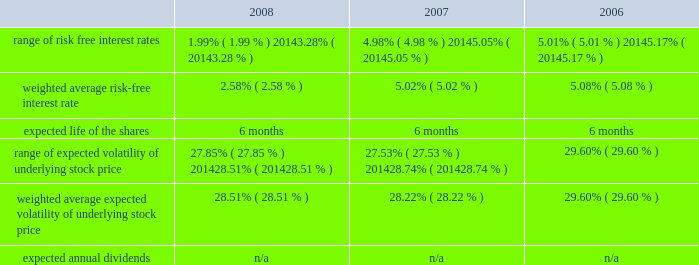American tower corporation and subsidiaries notes to consolidated financial statements 2014 ( continued ) from december 1 through may 31 of each year .
During the 2008 , 2007 and 2006 offering periods employees purchased 55764 , 48886 and 53210 shares , respectively , at weighted average prices per share of $ 30.08 , $ 33.93 and $ 24.98 , respectively .
The fair value of the espp offerings is estimated on the offering period commencement date using a black-scholes pricing model with the expense recognized over the expected life , which is the six month offering period over which employees accumulate payroll deductions to purchase the company 2019s common stock .
The weighted average fair value for the espp shares purchased during 2008 , 2007 and 2006 were $ 7.89 , $ 9.09 and $ 6.79 , respectively .
At december 31 , 2008 , 8.8 million shares remain reserved for future issuance under the plan .
Key assumptions used to apply this pricing model for the years ended december 31 , are as follows: .
13 .
Stockholders 2019 equity warrants 2014in january 2003 , the company issued warrants to purchase approximately 11.4 million shares of its common stock in connection with an offering of 808000 units , each consisting of $ 1000 principal amount at maturity of ati 12.25% ( 12.25 % ) senior subordinated discount notes due 2008 and a warrant to purchase 14.0953 shares of the company 2019s common stock .
These warrants became exercisable on january 29 , 2006 at an exercise price of $ 0.01 per share .
As these warrants expired on august 1 , 2008 , none were outstanding as of december 31 , in august 2005 , the company completed its merger with spectrasite , inc .
And assumed outstanding warrants to purchase shares of spectrasite , inc .
Common stock .
As of the merger completion date , each warrant was exercisable for two shares of spectrasite , inc .
Common stock at an exercise price of $ 32 per warrant .
Upon completion of the merger , each warrant to purchase shares of spectrasite , inc .
Common stock automatically converted into a warrant to purchase shares of the company 2019s common stock , such that upon exercise of each warrant , the holder has a right to receive 3.575 shares of the company 2019s common stock in lieu of each share of spectrasite , inc .
Common stock that would have been receivable under each assumed warrant prior to the merger .
Upon completion of the company 2019s merger with spectrasite , inc. , these warrants were exercisable for approximately 6.8 million shares of common stock .
Of these warrants , warrants to purchase approximately 1.8 million and 2.0 million shares of common stock remained outstanding as of december 31 , 2008 and 2007 , respectively .
These warrants will expire on february 10 , 2010 .
Stock repurchase programs 2014during the year ended december 31 , 2008 , the company repurchased an aggregate of approximately 18.3 million shares of its common stock for an aggregate of $ 697.1 million , including commissions and fees , pursuant to its publicly announced stock repurchase programs , as described below. .
What is the growth rate in the price of espp shares purchased from 2006 to 2007? 
Computations: ((9.09 - 6.79) / 6.79)
Answer: 0.33873. 